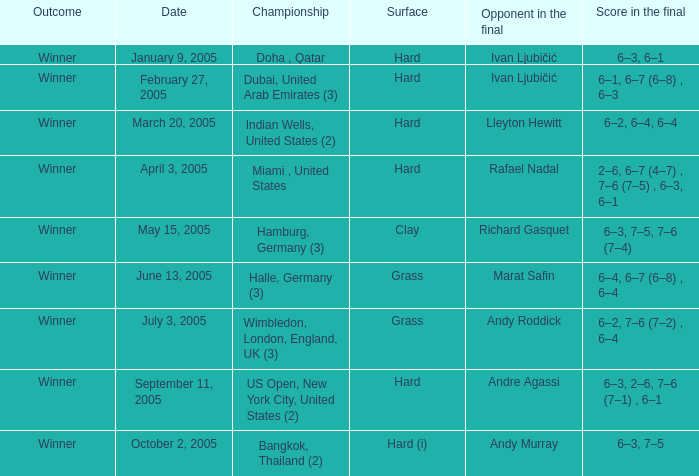I'm looking to parse the entire table for insights. Could you assist me with that? {'header': ['Outcome', 'Date', 'Championship', 'Surface', 'Opponent in the final', 'Score in the final'], 'rows': [['Winner', 'January 9, 2005', 'Doha , Qatar', 'Hard', 'Ivan Ljubičić', '6–3, 6–1'], ['Winner', 'February 27, 2005', 'Dubai, United Arab Emirates (3)', 'Hard', 'Ivan Ljubičić', '6–1, 6–7 (6–8) , 6–3'], ['Winner', 'March 20, 2005', 'Indian Wells, United States (2)', 'Hard', 'Lleyton Hewitt', '6–2, 6–4, 6–4'], ['Winner', 'April 3, 2005', 'Miami , United States', 'Hard', 'Rafael Nadal', '2–6, 6–7 (4–7) , 7–6 (7–5) , 6–3, 6–1'], ['Winner', 'May 15, 2005', 'Hamburg, Germany (3)', 'Clay', 'Richard Gasquet', '6–3, 7–5, 7–6 (7–4)'], ['Winner', 'June 13, 2005', 'Halle, Germany (3)', 'Grass', 'Marat Safin', '6–4, 6–7 (6–8) , 6–4'], ['Winner', 'July 3, 2005', 'Wimbledon, London, England, UK (3)', 'Grass', 'Andy Roddick', '6–2, 7–6 (7–2) , 6–4'], ['Winner', 'September 11, 2005', 'US Open, New York City, United States (2)', 'Hard', 'Andre Agassi', '6–3, 2–6, 7–6 (7–1) , 6–1'], ['Winner', 'October 2, 2005', 'Bangkok, Thailand (2)', 'Hard (i)', 'Andy Murray', '6–3, 7–5']]} In the championship Indian Wells, United States (2), who are the opponents in the final? Lleyton Hewitt. 